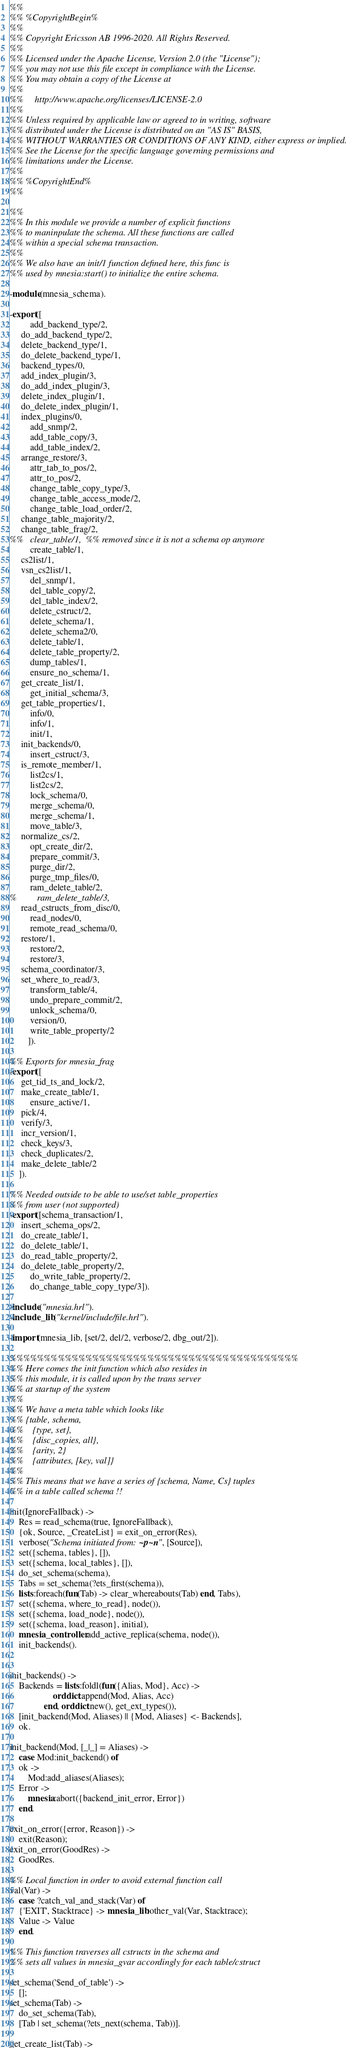<code> <loc_0><loc_0><loc_500><loc_500><_Erlang_>%%
%% %CopyrightBegin%
%%
%% Copyright Ericsson AB 1996-2020. All Rights Reserved.
%%
%% Licensed under the Apache License, Version 2.0 (the "License");
%% you may not use this file except in compliance with the License.
%% You may obtain a copy of the License at
%%
%%     http://www.apache.org/licenses/LICENSE-2.0
%%
%% Unless required by applicable law or agreed to in writing, software
%% distributed under the License is distributed on an "AS IS" BASIS,
%% WITHOUT WARRANTIES OR CONDITIONS OF ANY KIND, either express or implied.
%% See the License for the specific language governing permissions and
%% limitations under the License.
%%
%% %CopyrightEnd%
%%

%%
%% In this module we provide a number of explicit functions
%% to maninpulate the schema. All these functions are called
%% within a special schema transaction.
%%
%% We also have an init/1 function defined here, this func is
%% used by mnesia:start() to initialize the entire schema.

-module(mnesia_schema).

-export([
         add_backend_type/2,
	 do_add_backend_type/2,
	 delete_backend_type/1,
	 do_delete_backend_type/1,
	 backend_types/0,
	 add_index_plugin/3,
	 do_add_index_plugin/3,
	 delete_index_plugin/1,
	 do_delete_index_plugin/1,
	 index_plugins/0,
         add_snmp/2,
         add_table_copy/3,
         add_table_index/2,
	 arrange_restore/3,
         attr_tab_to_pos/2,
         attr_to_pos/2,
         change_table_copy_type/3,
         change_table_access_mode/2,
         change_table_load_order/2,
	 change_table_majority/2,
	 change_table_frag/2,
%%	 clear_table/1,  %% removed since it is not a schema op anymore
         create_table/1,
	 cs2list/1,
	 vsn_cs2list/1,
         del_snmp/1,
         del_table_copy/2,
         del_table_index/2,
         delete_cstruct/2,
         delete_schema/1,
         delete_schema2/0,
         delete_table/1,
         delete_table_property/2,
         dump_tables/1,
         ensure_no_schema/1,
	 get_create_list/1,
         get_initial_schema/3,
	 get_table_properties/1,
         info/0,
         info/1,
         init/1,
	 init_backends/0,
         insert_cstruct/3,
	 is_remote_member/1,
         list2cs/1,
         list2cs/2,
         lock_schema/0,
         merge_schema/0,
         merge_schema/1,
         move_table/3,
	 normalize_cs/2,
         opt_create_dir/2,
         prepare_commit/3,
         purge_dir/2,
         purge_tmp_files/0,
         ram_delete_table/2,
%         ram_delete_table/3,
	 read_cstructs_from_disc/0,
         read_nodes/0,
         remote_read_schema/0,
	 restore/1,
         restore/2,
         restore/3,
	 schema_coordinator/3,
	 set_where_to_read/3,
         transform_table/4,
         undo_prepare_commit/2,
         unlock_schema/0,
         version/0,
         write_table_property/2
        ]).

%% Exports for mnesia_frag
-export([
	 get_tid_ts_and_lock/2,
	 make_create_table/1,
         ensure_active/1,
	 pick/4,
	 verify/3,
	 incr_version/1,
	 check_keys/3,
	 check_duplicates/2,
	 make_delete_table/2
	]).

%% Needed outside to be able to use/set table_properties
%% from user (not supported)
-export([schema_transaction/1,
	 insert_schema_ops/2,
	 do_create_table/1,
	 do_delete_table/1,
	 do_read_table_property/2,
	 do_delete_table_property/2,
         do_write_table_property/2,
         do_change_table_copy_type/3]).

-include("mnesia.hrl").
-include_lib("kernel/include/file.hrl").

-import(mnesia_lib, [set/2, del/2, verbose/2, dbg_out/2]).

%%%%%%%%%%%%%%%%%%%%%%%%%%%%%%%%%%%%%%%%%%
%% Here comes the init function which also resides in
%% this module, it is called upon by the trans server
%% at startup of the system
%%
%% We have a meta table which looks like
%% {table, schema,
%%    {type, set},
%%    {disc_copies, all},
%%    {arity, 2}
%%    {attributes, [key, val]}
%%
%% This means that we have a series of {schema, Name, Cs} tuples
%% in a table called schema !!

init(IgnoreFallback) ->
    Res = read_schema(true, IgnoreFallback),
    {ok, Source, _CreateList} = exit_on_error(Res),
    verbose("Schema initiated from: ~p~n", [Source]),
    set({schema, tables}, []),
    set({schema, local_tables}, []),
    do_set_schema(schema),
    Tabs = set_schema(?ets_first(schema)),
    lists:foreach(fun(Tab) -> clear_whereabouts(Tab) end, Tabs),
    set({schema, where_to_read}, node()),
    set({schema, load_node}, node()),
    set({schema, load_reason}, initial),
    mnesia_controller:add_active_replica(schema, node()),
    init_backends().


init_backends() ->
    Backends = lists:foldl(fun({Alias, Mod}, Acc) ->
				   orddict:append(Mod, Alias, Acc)
			   end, orddict:new(), get_ext_types()),
    [init_backend(Mod, Aliases) || {Mod, Aliases} <- Backends],
    ok.

init_backend(Mod, [_|_] = Aliases) ->
    case Mod:init_backend() of
	ok ->
	    Mod:add_aliases(Aliases);
	Error ->
	    mnesia:abort({backend_init_error, Error})
    end.

exit_on_error({error, Reason}) ->
    exit(Reason);
exit_on_error(GoodRes) ->
    GoodRes.

%% Local function in order to avoid external function call
val(Var) ->
    case ?catch_val_and_stack(Var) of
	{'EXIT', Stacktrace} -> mnesia_lib:other_val(Var, Stacktrace);
	Value -> Value
    end.

%% This function traverses all cstructs in the schema and
%% sets all values in mnesia_gvar accordingly for each table/cstruct

set_schema('$end_of_table') ->
    [];
set_schema(Tab) ->
    do_set_schema(Tab),
    [Tab | set_schema(?ets_next(schema, Tab))].

get_create_list(Tab) -></code> 